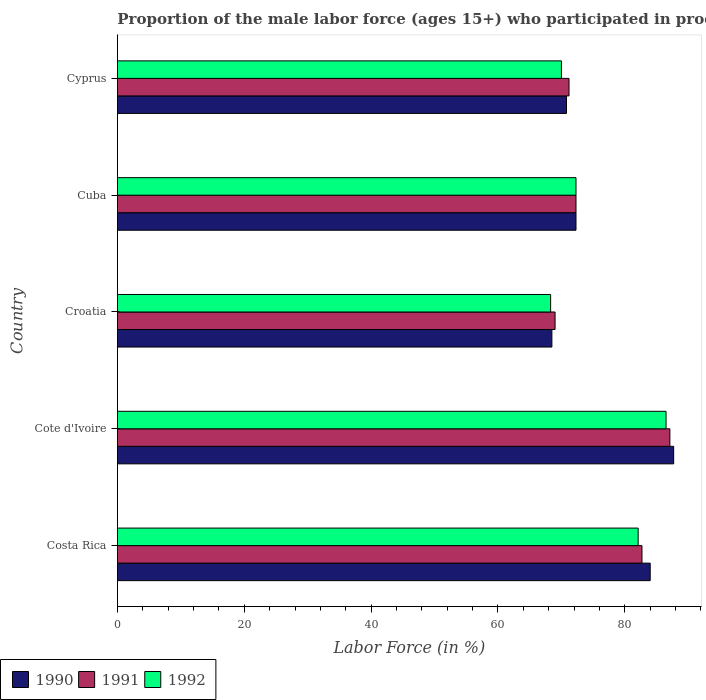How many groups of bars are there?
Your response must be concise. 5. Are the number of bars per tick equal to the number of legend labels?
Your response must be concise. Yes. How many bars are there on the 5th tick from the top?
Ensure brevity in your answer.  3. How many bars are there on the 1st tick from the bottom?
Provide a short and direct response. 3. What is the label of the 4th group of bars from the top?
Offer a terse response. Cote d'Ivoire. In how many cases, is the number of bars for a given country not equal to the number of legend labels?
Keep it short and to the point. 0. What is the proportion of the male labor force who participated in production in 1990 in Cote d'Ivoire?
Your answer should be compact. 87.7. Across all countries, what is the maximum proportion of the male labor force who participated in production in 1990?
Give a very brief answer. 87.7. Across all countries, what is the minimum proportion of the male labor force who participated in production in 1992?
Give a very brief answer. 68.3. In which country was the proportion of the male labor force who participated in production in 1990 maximum?
Give a very brief answer. Cote d'Ivoire. In which country was the proportion of the male labor force who participated in production in 1990 minimum?
Ensure brevity in your answer.  Croatia. What is the total proportion of the male labor force who participated in production in 1990 in the graph?
Ensure brevity in your answer.  383.3. What is the difference between the proportion of the male labor force who participated in production in 1991 in Croatia and that in Cyprus?
Your response must be concise. -2.2. What is the difference between the proportion of the male labor force who participated in production in 1992 in Croatia and the proportion of the male labor force who participated in production in 1991 in Cyprus?
Keep it short and to the point. -2.9. What is the average proportion of the male labor force who participated in production in 1992 per country?
Ensure brevity in your answer.  75.84. What is the difference between the proportion of the male labor force who participated in production in 1990 and proportion of the male labor force who participated in production in 1992 in Cote d'Ivoire?
Your answer should be compact. 1.2. What is the ratio of the proportion of the male labor force who participated in production in 1990 in Croatia to that in Cuba?
Offer a terse response. 0.95. What is the difference between the highest and the second highest proportion of the male labor force who participated in production in 1991?
Ensure brevity in your answer.  4.4. What is the difference between the highest and the lowest proportion of the male labor force who participated in production in 1990?
Provide a short and direct response. 19.2. Is the sum of the proportion of the male labor force who participated in production in 1990 in Cote d'Ivoire and Cyprus greater than the maximum proportion of the male labor force who participated in production in 1992 across all countries?
Keep it short and to the point. Yes. What does the 3rd bar from the top in Croatia represents?
Offer a terse response. 1990. Are the values on the major ticks of X-axis written in scientific E-notation?
Your response must be concise. No. Does the graph contain any zero values?
Make the answer very short. No. Does the graph contain grids?
Your answer should be very brief. No. Where does the legend appear in the graph?
Keep it short and to the point. Bottom left. What is the title of the graph?
Your answer should be compact. Proportion of the male labor force (ages 15+) who participated in production. What is the label or title of the X-axis?
Ensure brevity in your answer.  Labor Force (in %). What is the label or title of the Y-axis?
Give a very brief answer. Country. What is the Labor Force (in %) of 1991 in Costa Rica?
Provide a short and direct response. 82.7. What is the Labor Force (in %) in 1992 in Costa Rica?
Your response must be concise. 82.1. What is the Labor Force (in %) of 1990 in Cote d'Ivoire?
Make the answer very short. 87.7. What is the Labor Force (in %) in 1991 in Cote d'Ivoire?
Your response must be concise. 87.1. What is the Labor Force (in %) of 1992 in Cote d'Ivoire?
Provide a succinct answer. 86.5. What is the Labor Force (in %) in 1990 in Croatia?
Keep it short and to the point. 68.5. What is the Labor Force (in %) in 1992 in Croatia?
Your answer should be very brief. 68.3. What is the Labor Force (in %) of 1990 in Cuba?
Provide a succinct answer. 72.3. What is the Labor Force (in %) in 1991 in Cuba?
Provide a succinct answer. 72.3. What is the Labor Force (in %) in 1992 in Cuba?
Keep it short and to the point. 72.3. What is the Labor Force (in %) in 1990 in Cyprus?
Keep it short and to the point. 70.8. What is the Labor Force (in %) in 1991 in Cyprus?
Make the answer very short. 71.2. Across all countries, what is the maximum Labor Force (in %) of 1990?
Give a very brief answer. 87.7. Across all countries, what is the maximum Labor Force (in %) in 1991?
Make the answer very short. 87.1. Across all countries, what is the maximum Labor Force (in %) in 1992?
Provide a succinct answer. 86.5. Across all countries, what is the minimum Labor Force (in %) of 1990?
Make the answer very short. 68.5. Across all countries, what is the minimum Labor Force (in %) of 1991?
Your response must be concise. 69. Across all countries, what is the minimum Labor Force (in %) of 1992?
Your answer should be very brief. 68.3. What is the total Labor Force (in %) in 1990 in the graph?
Make the answer very short. 383.3. What is the total Labor Force (in %) in 1991 in the graph?
Keep it short and to the point. 382.3. What is the total Labor Force (in %) in 1992 in the graph?
Provide a short and direct response. 379.2. What is the difference between the Labor Force (in %) of 1990 in Costa Rica and that in Cote d'Ivoire?
Your answer should be compact. -3.7. What is the difference between the Labor Force (in %) in 1991 in Costa Rica and that in Cote d'Ivoire?
Provide a short and direct response. -4.4. What is the difference between the Labor Force (in %) in 1990 in Costa Rica and that in Cuba?
Make the answer very short. 11.7. What is the difference between the Labor Force (in %) of 1991 in Costa Rica and that in Cuba?
Provide a short and direct response. 10.4. What is the difference between the Labor Force (in %) in 1992 in Costa Rica and that in Cyprus?
Give a very brief answer. 12.1. What is the difference between the Labor Force (in %) in 1990 in Cote d'Ivoire and that in Croatia?
Offer a terse response. 19.2. What is the difference between the Labor Force (in %) in 1992 in Cote d'Ivoire and that in Croatia?
Ensure brevity in your answer.  18.2. What is the difference between the Labor Force (in %) in 1990 in Cote d'Ivoire and that in Cuba?
Offer a terse response. 15.4. What is the difference between the Labor Force (in %) of 1991 in Cote d'Ivoire and that in Cuba?
Your answer should be very brief. 14.8. What is the difference between the Labor Force (in %) of 1992 in Cote d'Ivoire and that in Cuba?
Offer a terse response. 14.2. What is the difference between the Labor Force (in %) of 1991 in Cote d'Ivoire and that in Cyprus?
Your answer should be compact. 15.9. What is the difference between the Labor Force (in %) of 1992 in Croatia and that in Cuba?
Give a very brief answer. -4. What is the difference between the Labor Force (in %) in 1991 in Croatia and that in Cyprus?
Ensure brevity in your answer.  -2.2. What is the difference between the Labor Force (in %) in 1990 in Costa Rica and the Labor Force (in %) in 1991 in Cote d'Ivoire?
Offer a very short reply. -3.1. What is the difference between the Labor Force (in %) in 1990 in Costa Rica and the Labor Force (in %) in 1992 in Cote d'Ivoire?
Keep it short and to the point. -2.5. What is the difference between the Labor Force (in %) in 1990 in Costa Rica and the Labor Force (in %) in 1992 in Croatia?
Your answer should be very brief. 15.7. What is the difference between the Labor Force (in %) of 1991 in Costa Rica and the Labor Force (in %) of 1992 in Croatia?
Offer a very short reply. 14.4. What is the difference between the Labor Force (in %) of 1990 in Costa Rica and the Labor Force (in %) of 1991 in Cuba?
Your response must be concise. 11.7. What is the difference between the Labor Force (in %) in 1990 in Costa Rica and the Labor Force (in %) in 1992 in Cuba?
Offer a terse response. 11.7. What is the difference between the Labor Force (in %) of 1991 in Costa Rica and the Labor Force (in %) of 1992 in Cuba?
Ensure brevity in your answer.  10.4. What is the difference between the Labor Force (in %) of 1990 in Costa Rica and the Labor Force (in %) of 1991 in Cyprus?
Your response must be concise. 12.8. What is the difference between the Labor Force (in %) in 1990 in Costa Rica and the Labor Force (in %) in 1992 in Cyprus?
Offer a terse response. 14. What is the difference between the Labor Force (in %) in 1991 in Costa Rica and the Labor Force (in %) in 1992 in Cyprus?
Make the answer very short. 12.7. What is the difference between the Labor Force (in %) of 1990 in Cote d'Ivoire and the Labor Force (in %) of 1992 in Croatia?
Your answer should be very brief. 19.4. What is the difference between the Labor Force (in %) of 1991 in Cote d'Ivoire and the Labor Force (in %) of 1992 in Croatia?
Your answer should be very brief. 18.8. What is the difference between the Labor Force (in %) in 1990 in Cote d'Ivoire and the Labor Force (in %) in 1991 in Cuba?
Offer a terse response. 15.4. What is the difference between the Labor Force (in %) of 1991 in Cote d'Ivoire and the Labor Force (in %) of 1992 in Cuba?
Give a very brief answer. 14.8. What is the difference between the Labor Force (in %) of 1991 in Cote d'Ivoire and the Labor Force (in %) of 1992 in Cyprus?
Offer a terse response. 17.1. What is the difference between the Labor Force (in %) in 1990 in Croatia and the Labor Force (in %) in 1992 in Cuba?
Your answer should be very brief. -3.8. What is the difference between the Labor Force (in %) of 1991 in Croatia and the Labor Force (in %) of 1992 in Cuba?
Offer a very short reply. -3.3. What is the difference between the Labor Force (in %) in 1990 in Croatia and the Labor Force (in %) in 1991 in Cyprus?
Your response must be concise. -2.7. What is the average Labor Force (in %) of 1990 per country?
Make the answer very short. 76.66. What is the average Labor Force (in %) in 1991 per country?
Offer a very short reply. 76.46. What is the average Labor Force (in %) in 1992 per country?
Make the answer very short. 75.84. What is the difference between the Labor Force (in %) of 1991 and Labor Force (in %) of 1992 in Costa Rica?
Your answer should be very brief. 0.6. What is the difference between the Labor Force (in %) in 1990 and Labor Force (in %) in 1992 in Cote d'Ivoire?
Ensure brevity in your answer.  1.2. What is the difference between the Labor Force (in %) of 1990 and Labor Force (in %) of 1991 in Croatia?
Provide a succinct answer. -0.5. What is the difference between the Labor Force (in %) of 1990 and Labor Force (in %) of 1991 in Cuba?
Keep it short and to the point. 0. What is the difference between the Labor Force (in %) of 1990 and Labor Force (in %) of 1991 in Cyprus?
Provide a short and direct response. -0.4. What is the difference between the Labor Force (in %) in 1990 and Labor Force (in %) in 1992 in Cyprus?
Keep it short and to the point. 0.8. What is the difference between the Labor Force (in %) of 1991 and Labor Force (in %) of 1992 in Cyprus?
Make the answer very short. 1.2. What is the ratio of the Labor Force (in %) in 1990 in Costa Rica to that in Cote d'Ivoire?
Your response must be concise. 0.96. What is the ratio of the Labor Force (in %) in 1991 in Costa Rica to that in Cote d'Ivoire?
Offer a terse response. 0.95. What is the ratio of the Labor Force (in %) of 1992 in Costa Rica to that in Cote d'Ivoire?
Your answer should be very brief. 0.95. What is the ratio of the Labor Force (in %) in 1990 in Costa Rica to that in Croatia?
Provide a short and direct response. 1.23. What is the ratio of the Labor Force (in %) in 1991 in Costa Rica to that in Croatia?
Keep it short and to the point. 1.2. What is the ratio of the Labor Force (in %) of 1992 in Costa Rica to that in Croatia?
Your response must be concise. 1.2. What is the ratio of the Labor Force (in %) of 1990 in Costa Rica to that in Cuba?
Keep it short and to the point. 1.16. What is the ratio of the Labor Force (in %) in 1991 in Costa Rica to that in Cuba?
Give a very brief answer. 1.14. What is the ratio of the Labor Force (in %) in 1992 in Costa Rica to that in Cuba?
Offer a very short reply. 1.14. What is the ratio of the Labor Force (in %) in 1990 in Costa Rica to that in Cyprus?
Provide a short and direct response. 1.19. What is the ratio of the Labor Force (in %) of 1991 in Costa Rica to that in Cyprus?
Ensure brevity in your answer.  1.16. What is the ratio of the Labor Force (in %) of 1992 in Costa Rica to that in Cyprus?
Your response must be concise. 1.17. What is the ratio of the Labor Force (in %) of 1990 in Cote d'Ivoire to that in Croatia?
Your answer should be very brief. 1.28. What is the ratio of the Labor Force (in %) in 1991 in Cote d'Ivoire to that in Croatia?
Your answer should be compact. 1.26. What is the ratio of the Labor Force (in %) in 1992 in Cote d'Ivoire to that in Croatia?
Give a very brief answer. 1.27. What is the ratio of the Labor Force (in %) in 1990 in Cote d'Ivoire to that in Cuba?
Make the answer very short. 1.21. What is the ratio of the Labor Force (in %) in 1991 in Cote d'Ivoire to that in Cuba?
Ensure brevity in your answer.  1.2. What is the ratio of the Labor Force (in %) of 1992 in Cote d'Ivoire to that in Cuba?
Offer a terse response. 1.2. What is the ratio of the Labor Force (in %) of 1990 in Cote d'Ivoire to that in Cyprus?
Your answer should be very brief. 1.24. What is the ratio of the Labor Force (in %) of 1991 in Cote d'Ivoire to that in Cyprus?
Provide a short and direct response. 1.22. What is the ratio of the Labor Force (in %) of 1992 in Cote d'Ivoire to that in Cyprus?
Your answer should be compact. 1.24. What is the ratio of the Labor Force (in %) in 1991 in Croatia to that in Cuba?
Offer a very short reply. 0.95. What is the ratio of the Labor Force (in %) of 1992 in Croatia to that in Cuba?
Offer a very short reply. 0.94. What is the ratio of the Labor Force (in %) in 1990 in Croatia to that in Cyprus?
Offer a terse response. 0.97. What is the ratio of the Labor Force (in %) in 1991 in Croatia to that in Cyprus?
Ensure brevity in your answer.  0.97. What is the ratio of the Labor Force (in %) in 1992 in Croatia to that in Cyprus?
Offer a very short reply. 0.98. What is the ratio of the Labor Force (in %) of 1990 in Cuba to that in Cyprus?
Provide a succinct answer. 1.02. What is the ratio of the Labor Force (in %) of 1991 in Cuba to that in Cyprus?
Your response must be concise. 1.02. What is the ratio of the Labor Force (in %) of 1992 in Cuba to that in Cyprus?
Your response must be concise. 1.03. What is the difference between the highest and the lowest Labor Force (in %) in 1990?
Your answer should be very brief. 19.2. What is the difference between the highest and the lowest Labor Force (in %) in 1992?
Offer a terse response. 18.2. 